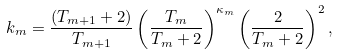Convert formula to latex. <formula><loc_0><loc_0><loc_500><loc_500>k _ { m } = \frac { ( T _ { m + 1 } + 2 ) } { T _ { m + 1 } } \left ( \frac { T _ { m } } { T _ { m } + 2 } \right ) ^ { \kappa _ { m } } \left ( \frac { 2 } { T _ { m } + 2 } \right ) ^ { 2 } ,</formula> 